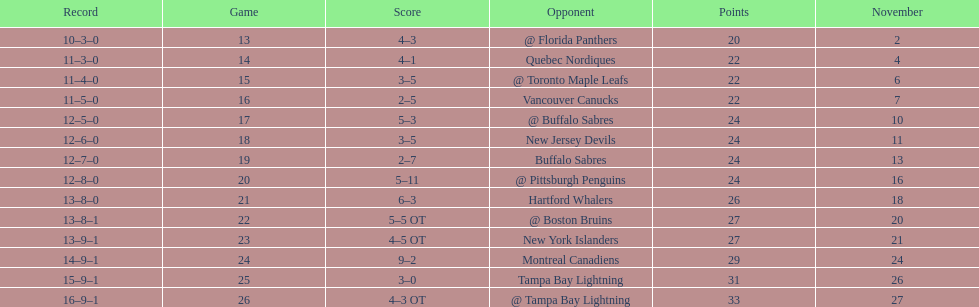Did the tampa bay lightning record the fewest victories? Yes. 